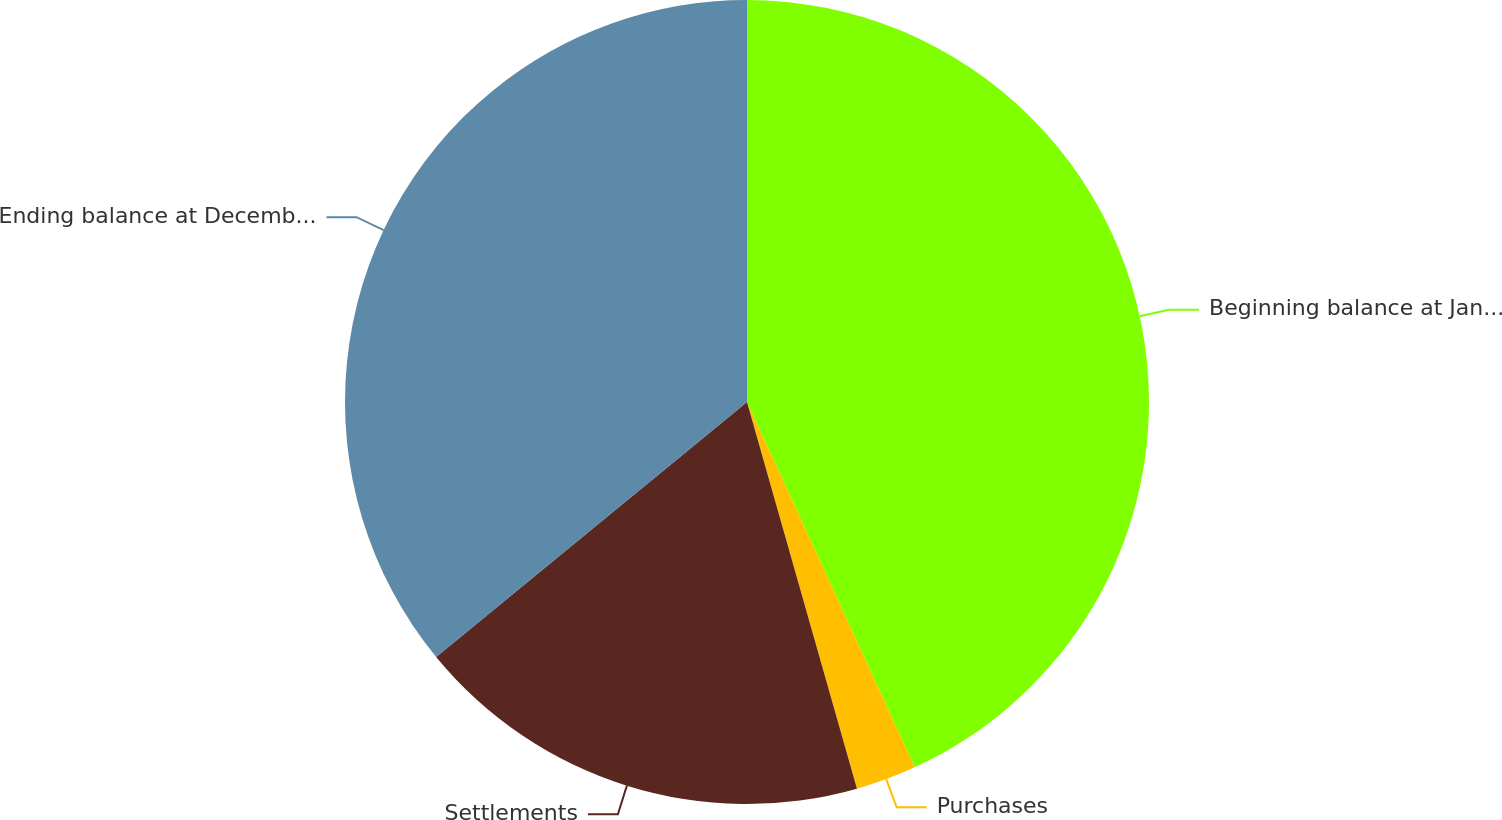<chart> <loc_0><loc_0><loc_500><loc_500><pie_chart><fcel>Beginning balance at January 1<fcel>Purchases<fcel>Settlements<fcel>Ending balance at December 31<nl><fcel>43.15%<fcel>2.44%<fcel>18.48%<fcel>35.93%<nl></chart> 